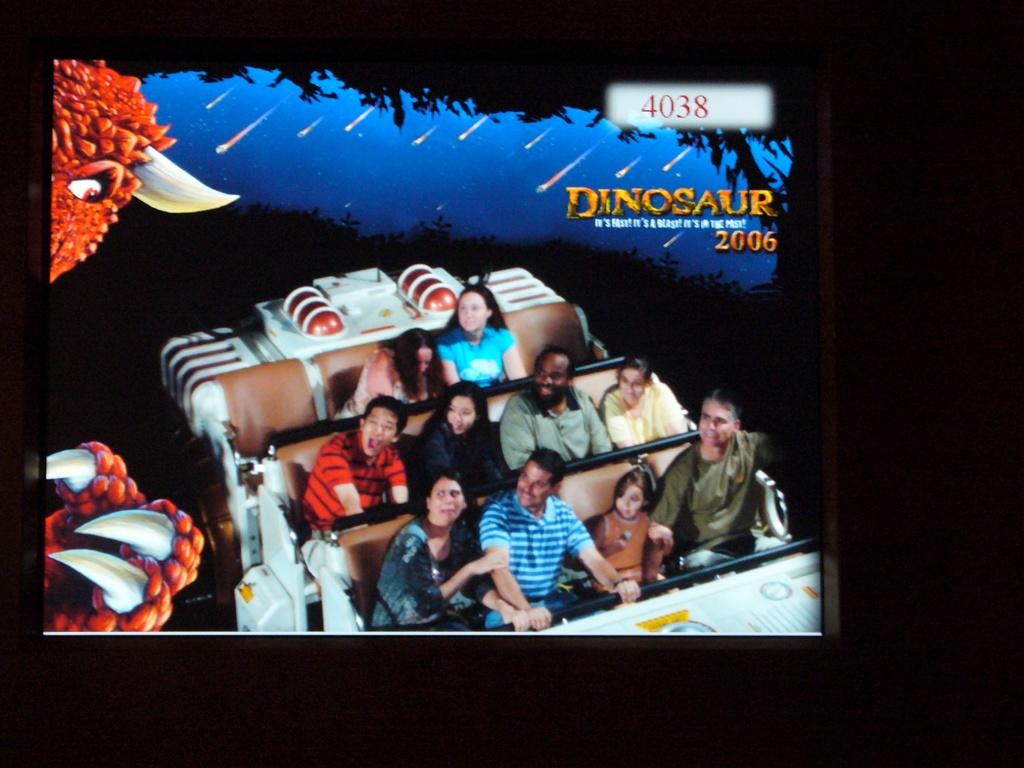What's the year under dinosaur?
Your response must be concise. 2006. What word is above the year on the right hand side?
Your answer should be very brief. Dinosaur. 